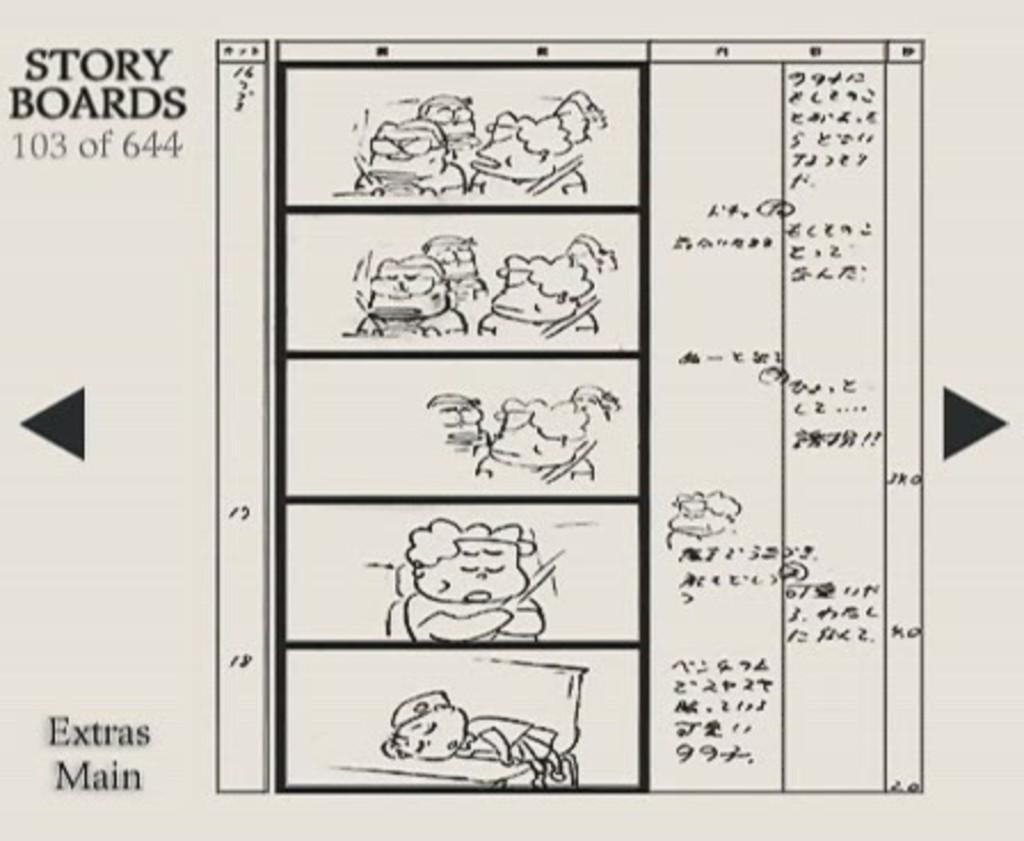What is present on the white paper in the image? There is text and cartoon images on the white paper in the image. Can you describe the type of text in the image? The provided facts do not specify the type of text, so we cannot describe it. What is the style of the images in the image? The images in the image are cartoon-style. What type of slip is the grandfather wearing in the image? There is no grandfather or slip present in the image. What type of law does the lawyer specialize in, as depicted in the image? There is no lawyer or legal information present in the image. 